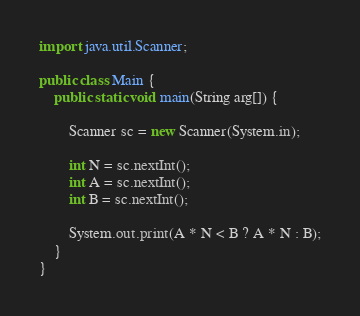Convert code to text. <code><loc_0><loc_0><loc_500><loc_500><_Java_>
import java.util.Scanner;

public class Main {
	public static void main(String arg[]) {

		Scanner sc = new Scanner(System.in);

		int N = sc.nextInt();
		int A = sc.nextInt();
		int B = sc.nextInt();

		System.out.print(A * N < B ? A * N : B);
	}
}</code> 